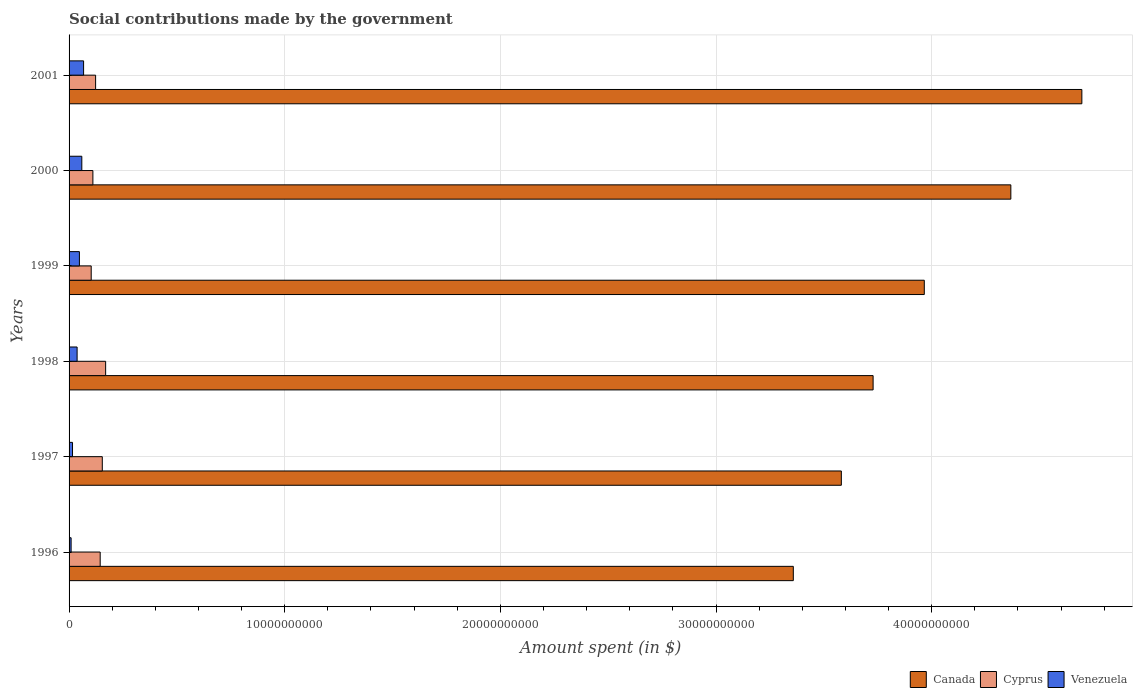How many different coloured bars are there?
Keep it short and to the point. 3. How many groups of bars are there?
Your response must be concise. 6. How many bars are there on the 4th tick from the top?
Provide a succinct answer. 3. How many bars are there on the 2nd tick from the bottom?
Offer a very short reply. 3. What is the amount spent on social contributions in Venezuela in 2001?
Keep it short and to the point. 6.74e+08. Across all years, what is the maximum amount spent on social contributions in Venezuela?
Offer a terse response. 6.74e+08. Across all years, what is the minimum amount spent on social contributions in Canada?
Provide a succinct answer. 3.36e+1. In which year was the amount spent on social contributions in Cyprus minimum?
Your answer should be compact. 1999. What is the total amount spent on social contributions in Cyprus in the graph?
Your response must be concise. 8.04e+09. What is the difference between the amount spent on social contributions in Venezuela in 1996 and that in 1997?
Provide a succinct answer. -6.55e+07. What is the difference between the amount spent on social contributions in Canada in 1997 and the amount spent on social contributions in Cyprus in 1999?
Your response must be concise. 3.48e+1. What is the average amount spent on social contributions in Cyprus per year?
Give a very brief answer. 1.34e+09. In the year 1998, what is the difference between the amount spent on social contributions in Canada and amount spent on social contributions in Cyprus?
Offer a terse response. 3.56e+1. In how many years, is the amount spent on social contributions in Cyprus greater than 46000000000 $?
Ensure brevity in your answer.  0. What is the ratio of the amount spent on social contributions in Cyprus in 1999 to that in 2001?
Offer a terse response. 0.83. Is the difference between the amount spent on social contributions in Canada in 1997 and 1998 greater than the difference between the amount spent on social contributions in Cyprus in 1997 and 1998?
Ensure brevity in your answer.  No. What is the difference between the highest and the second highest amount spent on social contributions in Cyprus?
Offer a terse response. 1.55e+08. What is the difference between the highest and the lowest amount spent on social contributions in Venezuela?
Provide a succinct answer. 5.79e+08. Is the sum of the amount spent on social contributions in Canada in 1996 and 2000 greater than the maximum amount spent on social contributions in Venezuela across all years?
Provide a short and direct response. Yes. What does the 2nd bar from the top in 1997 represents?
Your response must be concise. Cyprus. What does the 3rd bar from the bottom in 2000 represents?
Your response must be concise. Venezuela. Are all the bars in the graph horizontal?
Your answer should be compact. Yes. What is the difference between two consecutive major ticks on the X-axis?
Offer a very short reply. 1.00e+1. Are the values on the major ticks of X-axis written in scientific E-notation?
Provide a succinct answer. No. Does the graph contain grids?
Keep it short and to the point. Yes. Where does the legend appear in the graph?
Your answer should be very brief. Bottom right. How many legend labels are there?
Provide a short and direct response. 3. How are the legend labels stacked?
Ensure brevity in your answer.  Horizontal. What is the title of the graph?
Offer a very short reply. Social contributions made by the government. Does "United Arab Emirates" appear as one of the legend labels in the graph?
Give a very brief answer. No. What is the label or title of the X-axis?
Offer a very short reply. Amount spent (in $). What is the label or title of the Y-axis?
Keep it short and to the point. Years. What is the Amount spent (in $) in Canada in 1996?
Offer a very short reply. 3.36e+1. What is the Amount spent (in $) in Cyprus in 1996?
Give a very brief answer. 1.44e+09. What is the Amount spent (in $) of Venezuela in 1996?
Your answer should be very brief. 9.45e+07. What is the Amount spent (in $) in Canada in 1997?
Your answer should be compact. 3.58e+1. What is the Amount spent (in $) in Cyprus in 1997?
Keep it short and to the point. 1.54e+09. What is the Amount spent (in $) of Venezuela in 1997?
Offer a very short reply. 1.60e+08. What is the Amount spent (in $) in Canada in 1998?
Your answer should be compact. 3.73e+1. What is the Amount spent (in $) in Cyprus in 1998?
Make the answer very short. 1.70e+09. What is the Amount spent (in $) of Venezuela in 1998?
Your answer should be very brief. 3.72e+08. What is the Amount spent (in $) of Canada in 1999?
Offer a terse response. 3.97e+1. What is the Amount spent (in $) of Cyprus in 1999?
Offer a very short reply. 1.03e+09. What is the Amount spent (in $) of Venezuela in 1999?
Give a very brief answer. 4.79e+08. What is the Amount spent (in $) in Canada in 2000?
Give a very brief answer. 4.37e+1. What is the Amount spent (in $) in Cyprus in 2000?
Make the answer very short. 1.10e+09. What is the Amount spent (in $) in Venezuela in 2000?
Your response must be concise. 5.91e+08. What is the Amount spent (in $) in Canada in 2001?
Give a very brief answer. 4.70e+1. What is the Amount spent (in $) of Cyprus in 2001?
Offer a terse response. 1.23e+09. What is the Amount spent (in $) in Venezuela in 2001?
Keep it short and to the point. 6.74e+08. Across all years, what is the maximum Amount spent (in $) in Canada?
Keep it short and to the point. 4.70e+1. Across all years, what is the maximum Amount spent (in $) of Cyprus?
Offer a very short reply. 1.70e+09. Across all years, what is the maximum Amount spent (in $) of Venezuela?
Offer a terse response. 6.74e+08. Across all years, what is the minimum Amount spent (in $) of Canada?
Provide a succinct answer. 3.36e+1. Across all years, what is the minimum Amount spent (in $) in Cyprus?
Your response must be concise. 1.03e+09. Across all years, what is the minimum Amount spent (in $) in Venezuela?
Provide a short and direct response. 9.45e+07. What is the total Amount spent (in $) in Canada in the graph?
Keep it short and to the point. 2.37e+11. What is the total Amount spent (in $) in Cyprus in the graph?
Your answer should be very brief. 8.04e+09. What is the total Amount spent (in $) in Venezuela in the graph?
Make the answer very short. 2.37e+09. What is the difference between the Amount spent (in $) of Canada in 1996 and that in 1997?
Make the answer very short. -2.23e+09. What is the difference between the Amount spent (in $) in Cyprus in 1996 and that in 1997?
Keep it short and to the point. -9.78e+07. What is the difference between the Amount spent (in $) in Venezuela in 1996 and that in 1997?
Your response must be concise. -6.55e+07. What is the difference between the Amount spent (in $) of Canada in 1996 and that in 1998?
Offer a terse response. -3.70e+09. What is the difference between the Amount spent (in $) of Cyprus in 1996 and that in 1998?
Make the answer very short. -2.53e+08. What is the difference between the Amount spent (in $) in Venezuela in 1996 and that in 1998?
Give a very brief answer. -2.78e+08. What is the difference between the Amount spent (in $) of Canada in 1996 and that in 1999?
Provide a succinct answer. -6.07e+09. What is the difference between the Amount spent (in $) of Cyprus in 1996 and that in 1999?
Your response must be concise. 4.17e+08. What is the difference between the Amount spent (in $) of Venezuela in 1996 and that in 1999?
Your response must be concise. -3.85e+08. What is the difference between the Amount spent (in $) of Canada in 1996 and that in 2000?
Keep it short and to the point. -1.01e+1. What is the difference between the Amount spent (in $) in Cyprus in 1996 and that in 2000?
Offer a terse response. 3.38e+08. What is the difference between the Amount spent (in $) in Venezuela in 1996 and that in 2000?
Offer a terse response. -4.96e+08. What is the difference between the Amount spent (in $) in Canada in 1996 and that in 2001?
Offer a terse response. -1.34e+1. What is the difference between the Amount spent (in $) in Cyprus in 1996 and that in 2001?
Provide a succinct answer. 2.12e+08. What is the difference between the Amount spent (in $) in Venezuela in 1996 and that in 2001?
Keep it short and to the point. -5.79e+08. What is the difference between the Amount spent (in $) of Canada in 1997 and that in 1998?
Your answer should be very brief. -1.47e+09. What is the difference between the Amount spent (in $) of Cyprus in 1997 and that in 1998?
Your answer should be very brief. -1.55e+08. What is the difference between the Amount spent (in $) in Venezuela in 1997 and that in 1998?
Your answer should be compact. -2.12e+08. What is the difference between the Amount spent (in $) of Canada in 1997 and that in 1999?
Your answer should be very brief. -3.85e+09. What is the difference between the Amount spent (in $) in Cyprus in 1997 and that in 1999?
Your answer should be compact. 5.14e+08. What is the difference between the Amount spent (in $) in Venezuela in 1997 and that in 1999?
Keep it short and to the point. -3.19e+08. What is the difference between the Amount spent (in $) of Canada in 1997 and that in 2000?
Make the answer very short. -7.86e+09. What is the difference between the Amount spent (in $) of Cyprus in 1997 and that in 2000?
Your answer should be compact. 4.36e+08. What is the difference between the Amount spent (in $) of Venezuela in 1997 and that in 2000?
Offer a very short reply. -4.30e+08. What is the difference between the Amount spent (in $) in Canada in 1997 and that in 2001?
Give a very brief answer. -1.12e+1. What is the difference between the Amount spent (in $) of Cyprus in 1997 and that in 2001?
Give a very brief answer. 3.10e+08. What is the difference between the Amount spent (in $) in Venezuela in 1997 and that in 2001?
Make the answer very short. -5.14e+08. What is the difference between the Amount spent (in $) of Canada in 1998 and that in 1999?
Give a very brief answer. -2.37e+09. What is the difference between the Amount spent (in $) in Cyprus in 1998 and that in 1999?
Offer a terse response. 6.69e+08. What is the difference between the Amount spent (in $) of Venezuela in 1998 and that in 1999?
Your answer should be compact. -1.07e+08. What is the difference between the Amount spent (in $) of Canada in 1998 and that in 2000?
Make the answer very short. -6.39e+09. What is the difference between the Amount spent (in $) in Cyprus in 1998 and that in 2000?
Your response must be concise. 5.91e+08. What is the difference between the Amount spent (in $) in Venezuela in 1998 and that in 2000?
Make the answer very short. -2.18e+08. What is the difference between the Amount spent (in $) of Canada in 1998 and that in 2001?
Keep it short and to the point. -9.68e+09. What is the difference between the Amount spent (in $) of Cyprus in 1998 and that in 2001?
Your answer should be very brief. 4.65e+08. What is the difference between the Amount spent (in $) of Venezuela in 1998 and that in 2001?
Give a very brief answer. -3.01e+08. What is the difference between the Amount spent (in $) of Canada in 1999 and that in 2000?
Ensure brevity in your answer.  -4.01e+09. What is the difference between the Amount spent (in $) in Cyprus in 1999 and that in 2000?
Offer a very short reply. -7.84e+07. What is the difference between the Amount spent (in $) of Venezuela in 1999 and that in 2000?
Your response must be concise. -1.11e+08. What is the difference between the Amount spent (in $) of Canada in 1999 and that in 2001?
Ensure brevity in your answer.  -7.31e+09. What is the difference between the Amount spent (in $) in Cyprus in 1999 and that in 2001?
Provide a short and direct response. -2.04e+08. What is the difference between the Amount spent (in $) of Venezuela in 1999 and that in 2001?
Keep it short and to the point. -1.94e+08. What is the difference between the Amount spent (in $) of Canada in 2000 and that in 2001?
Your answer should be very brief. -3.29e+09. What is the difference between the Amount spent (in $) in Cyprus in 2000 and that in 2001?
Provide a succinct answer. -1.26e+08. What is the difference between the Amount spent (in $) of Venezuela in 2000 and that in 2001?
Provide a succinct answer. -8.30e+07. What is the difference between the Amount spent (in $) of Canada in 1996 and the Amount spent (in $) of Cyprus in 1997?
Your response must be concise. 3.20e+1. What is the difference between the Amount spent (in $) of Canada in 1996 and the Amount spent (in $) of Venezuela in 1997?
Your answer should be compact. 3.34e+1. What is the difference between the Amount spent (in $) in Cyprus in 1996 and the Amount spent (in $) in Venezuela in 1997?
Give a very brief answer. 1.28e+09. What is the difference between the Amount spent (in $) of Canada in 1996 and the Amount spent (in $) of Cyprus in 1998?
Provide a short and direct response. 3.19e+1. What is the difference between the Amount spent (in $) in Canada in 1996 and the Amount spent (in $) in Venezuela in 1998?
Your answer should be very brief. 3.32e+1. What is the difference between the Amount spent (in $) in Cyprus in 1996 and the Amount spent (in $) in Venezuela in 1998?
Provide a short and direct response. 1.07e+09. What is the difference between the Amount spent (in $) in Canada in 1996 and the Amount spent (in $) in Cyprus in 1999?
Offer a terse response. 3.26e+1. What is the difference between the Amount spent (in $) of Canada in 1996 and the Amount spent (in $) of Venezuela in 1999?
Offer a terse response. 3.31e+1. What is the difference between the Amount spent (in $) of Cyprus in 1996 and the Amount spent (in $) of Venezuela in 1999?
Provide a succinct answer. 9.64e+08. What is the difference between the Amount spent (in $) in Canada in 1996 and the Amount spent (in $) in Cyprus in 2000?
Keep it short and to the point. 3.25e+1. What is the difference between the Amount spent (in $) of Canada in 1996 and the Amount spent (in $) of Venezuela in 2000?
Offer a very short reply. 3.30e+1. What is the difference between the Amount spent (in $) in Cyprus in 1996 and the Amount spent (in $) in Venezuela in 2000?
Offer a terse response. 8.53e+08. What is the difference between the Amount spent (in $) in Canada in 1996 and the Amount spent (in $) in Cyprus in 2001?
Offer a terse response. 3.24e+1. What is the difference between the Amount spent (in $) in Canada in 1996 and the Amount spent (in $) in Venezuela in 2001?
Give a very brief answer. 3.29e+1. What is the difference between the Amount spent (in $) of Cyprus in 1996 and the Amount spent (in $) of Venezuela in 2001?
Keep it short and to the point. 7.69e+08. What is the difference between the Amount spent (in $) in Canada in 1997 and the Amount spent (in $) in Cyprus in 1998?
Give a very brief answer. 3.41e+1. What is the difference between the Amount spent (in $) in Canada in 1997 and the Amount spent (in $) in Venezuela in 1998?
Your answer should be very brief. 3.54e+1. What is the difference between the Amount spent (in $) in Cyprus in 1997 and the Amount spent (in $) in Venezuela in 1998?
Give a very brief answer. 1.17e+09. What is the difference between the Amount spent (in $) of Canada in 1997 and the Amount spent (in $) of Cyprus in 1999?
Keep it short and to the point. 3.48e+1. What is the difference between the Amount spent (in $) of Canada in 1997 and the Amount spent (in $) of Venezuela in 1999?
Offer a terse response. 3.53e+1. What is the difference between the Amount spent (in $) of Cyprus in 1997 and the Amount spent (in $) of Venezuela in 1999?
Offer a terse response. 1.06e+09. What is the difference between the Amount spent (in $) of Canada in 1997 and the Amount spent (in $) of Cyprus in 2000?
Offer a very short reply. 3.47e+1. What is the difference between the Amount spent (in $) in Canada in 1997 and the Amount spent (in $) in Venezuela in 2000?
Keep it short and to the point. 3.52e+1. What is the difference between the Amount spent (in $) in Cyprus in 1997 and the Amount spent (in $) in Venezuela in 2000?
Offer a very short reply. 9.50e+08. What is the difference between the Amount spent (in $) of Canada in 1997 and the Amount spent (in $) of Cyprus in 2001?
Offer a terse response. 3.46e+1. What is the difference between the Amount spent (in $) of Canada in 1997 and the Amount spent (in $) of Venezuela in 2001?
Give a very brief answer. 3.51e+1. What is the difference between the Amount spent (in $) of Cyprus in 1997 and the Amount spent (in $) of Venezuela in 2001?
Offer a terse response. 8.67e+08. What is the difference between the Amount spent (in $) in Canada in 1998 and the Amount spent (in $) in Cyprus in 1999?
Offer a very short reply. 3.63e+1. What is the difference between the Amount spent (in $) of Canada in 1998 and the Amount spent (in $) of Venezuela in 1999?
Provide a succinct answer. 3.68e+1. What is the difference between the Amount spent (in $) in Cyprus in 1998 and the Amount spent (in $) in Venezuela in 1999?
Make the answer very short. 1.22e+09. What is the difference between the Amount spent (in $) in Canada in 1998 and the Amount spent (in $) in Cyprus in 2000?
Your answer should be very brief. 3.62e+1. What is the difference between the Amount spent (in $) in Canada in 1998 and the Amount spent (in $) in Venezuela in 2000?
Ensure brevity in your answer.  3.67e+1. What is the difference between the Amount spent (in $) in Cyprus in 1998 and the Amount spent (in $) in Venezuela in 2000?
Provide a succinct answer. 1.11e+09. What is the difference between the Amount spent (in $) of Canada in 1998 and the Amount spent (in $) of Cyprus in 2001?
Give a very brief answer. 3.61e+1. What is the difference between the Amount spent (in $) of Canada in 1998 and the Amount spent (in $) of Venezuela in 2001?
Offer a very short reply. 3.66e+1. What is the difference between the Amount spent (in $) in Cyprus in 1998 and the Amount spent (in $) in Venezuela in 2001?
Keep it short and to the point. 1.02e+09. What is the difference between the Amount spent (in $) in Canada in 1999 and the Amount spent (in $) in Cyprus in 2000?
Offer a very short reply. 3.86e+1. What is the difference between the Amount spent (in $) in Canada in 1999 and the Amount spent (in $) in Venezuela in 2000?
Your answer should be very brief. 3.91e+1. What is the difference between the Amount spent (in $) in Cyprus in 1999 and the Amount spent (in $) in Venezuela in 2000?
Give a very brief answer. 4.36e+08. What is the difference between the Amount spent (in $) of Canada in 1999 and the Amount spent (in $) of Cyprus in 2001?
Provide a short and direct response. 3.84e+1. What is the difference between the Amount spent (in $) of Canada in 1999 and the Amount spent (in $) of Venezuela in 2001?
Provide a short and direct response. 3.90e+1. What is the difference between the Amount spent (in $) in Cyprus in 1999 and the Amount spent (in $) in Venezuela in 2001?
Offer a terse response. 3.53e+08. What is the difference between the Amount spent (in $) of Canada in 2000 and the Amount spent (in $) of Cyprus in 2001?
Make the answer very short. 4.24e+1. What is the difference between the Amount spent (in $) of Canada in 2000 and the Amount spent (in $) of Venezuela in 2001?
Your answer should be very brief. 4.30e+1. What is the difference between the Amount spent (in $) in Cyprus in 2000 and the Amount spent (in $) in Venezuela in 2001?
Make the answer very short. 4.31e+08. What is the average Amount spent (in $) of Canada per year?
Offer a terse response. 3.95e+1. What is the average Amount spent (in $) of Cyprus per year?
Your response must be concise. 1.34e+09. What is the average Amount spent (in $) of Venezuela per year?
Offer a terse response. 3.95e+08. In the year 1996, what is the difference between the Amount spent (in $) of Canada and Amount spent (in $) of Cyprus?
Keep it short and to the point. 3.21e+1. In the year 1996, what is the difference between the Amount spent (in $) in Canada and Amount spent (in $) in Venezuela?
Make the answer very short. 3.35e+1. In the year 1996, what is the difference between the Amount spent (in $) in Cyprus and Amount spent (in $) in Venezuela?
Provide a succinct answer. 1.35e+09. In the year 1997, what is the difference between the Amount spent (in $) in Canada and Amount spent (in $) in Cyprus?
Offer a terse response. 3.43e+1. In the year 1997, what is the difference between the Amount spent (in $) of Canada and Amount spent (in $) of Venezuela?
Offer a very short reply. 3.57e+1. In the year 1997, what is the difference between the Amount spent (in $) of Cyprus and Amount spent (in $) of Venezuela?
Provide a succinct answer. 1.38e+09. In the year 1998, what is the difference between the Amount spent (in $) in Canada and Amount spent (in $) in Cyprus?
Your answer should be compact. 3.56e+1. In the year 1998, what is the difference between the Amount spent (in $) in Canada and Amount spent (in $) in Venezuela?
Give a very brief answer. 3.69e+1. In the year 1998, what is the difference between the Amount spent (in $) of Cyprus and Amount spent (in $) of Venezuela?
Give a very brief answer. 1.32e+09. In the year 1999, what is the difference between the Amount spent (in $) in Canada and Amount spent (in $) in Cyprus?
Offer a very short reply. 3.86e+1. In the year 1999, what is the difference between the Amount spent (in $) in Canada and Amount spent (in $) in Venezuela?
Provide a succinct answer. 3.92e+1. In the year 1999, what is the difference between the Amount spent (in $) in Cyprus and Amount spent (in $) in Venezuela?
Make the answer very short. 5.47e+08. In the year 2000, what is the difference between the Amount spent (in $) of Canada and Amount spent (in $) of Cyprus?
Keep it short and to the point. 4.26e+1. In the year 2000, what is the difference between the Amount spent (in $) in Canada and Amount spent (in $) in Venezuela?
Ensure brevity in your answer.  4.31e+1. In the year 2000, what is the difference between the Amount spent (in $) of Cyprus and Amount spent (in $) of Venezuela?
Your answer should be compact. 5.14e+08. In the year 2001, what is the difference between the Amount spent (in $) of Canada and Amount spent (in $) of Cyprus?
Give a very brief answer. 4.57e+1. In the year 2001, what is the difference between the Amount spent (in $) in Canada and Amount spent (in $) in Venezuela?
Keep it short and to the point. 4.63e+1. In the year 2001, what is the difference between the Amount spent (in $) of Cyprus and Amount spent (in $) of Venezuela?
Your answer should be compact. 5.57e+08. What is the ratio of the Amount spent (in $) of Canada in 1996 to that in 1997?
Your answer should be compact. 0.94. What is the ratio of the Amount spent (in $) of Cyprus in 1996 to that in 1997?
Make the answer very short. 0.94. What is the ratio of the Amount spent (in $) in Venezuela in 1996 to that in 1997?
Your answer should be compact. 0.59. What is the ratio of the Amount spent (in $) in Canada in 1996 to that in 1998?
Provide a short and direct response. 0.9. What is the ratio of the Amount spent (in $) of Cyprus in 1996 to that in 1998?
Ensure brevity in your answer.  0.85. What is the ratio of the Amount spent (in $) in Venezuela in 1996 to that in 1998?
Your answer should be very brief. 0.25. What is the ratio of the Amount spent (in $) in Canada in 1996 to that in 1999?
Provide a short and direct response. 0.85. What is the ratio of the Amount spent (in $) of Cyprus in 1996 to that in 1999?
Your response must be concise. 1.41. What is the ratio of the Amount spent (in $) in Venezuela in 1996 to that in 1999?
Your answer should be very brief. 0.2. What is the ratio of the Amount spent (in $) of Canada in 1996 to that in 2000?
Keep it short and to the point. 0.77. What is the ratio of the Amount spent (in $) in Cyprus in 1996 to that in 2000?
Offer a very short reply. 1.31. What is the ratio of the Amount spent (in $) of Venezuela in 1996 to that in 2000?
Provide a succinct answer. 0.16. What is the ratio of the Amount spent (in $) in Canada in 1996 to that in 2001?
Ensure brevity in your answer.  0.72. What is the ratio of the Amount spent (in $) of Cyprus in 1996 to that in 2001?
Offer a very short reply. 1.17. What is the ratio of the Amount spent (in $) of Venezuela in 1996 to that in 2001?
Make the answer very short. 0.14. What is the ratio of the Amount spent (in $) in Canada in 1997 to that in 1998?
Keep it short and to the point. 0.96. What is the ratio of the Amount spent (in $) of Cyprus in 1997 to that in 1998?
Provide a short and direct response. 0.91. What is the ratio of the Amount spent (in $) in Venezuela in 1997 to that in 1998?
Ensure brevity in your answer.  0.43. What is the ratio of the Amount spent (in $) of Canada in 1997 to that in 1999?
Make the answer very short. 0.9. What is the ratio of the Amount spent (in $) in Cyprus in 1997 to that in 1999?
Offer a very short reply. 1.5. What is the ratio of the Amount spent (in $) in Venezuela in 1997 to that in 1999?
Your answer should be compact. 0.33. What is the ratio of the Amount spent (in $) in Canada in 1997 to that in 2000?
Make the answer very short. 0.82. What is the ratio of the Amount spent (in $) of Cyprus in 1997 to that in 2000?
Ensure brevity in your answer.  1.39. What is the ratio of the Amount spent (in $) of Venezuela in 1997 to that in 2000?
Give a very brief answer. 0.27. What is the ratio of the Amount spent (in $) in Canada in 1997 to that in 2001?
Provide a succinct answer. 0.76. What is the ratio of the Amount spent (in $) in Cyprus in 1997 to that in 2001?
Offer a terse response. 1.25. What is the ratio of the Amount spent (in $) of Venezuela in 1997 to that in 2001?
Keep it short and to the point. 0.24. What is the ratio of the Amount spent (in $) in Canada in 1998 to that in 1999?
Your answer should be very brief. 0.94. What is the ratio of the Amount spent (in $) in Cyprus in 1998 to that in 1999?
Your answer should be very brief. 1.65. What is the ratio of the Amount spent (in $) of Venezuela in 1998 to that in 1999?
Keep it short and to the point. 0.78. What is the ratio of the Amount spent (in $) of Canada in 1998 to that in 2000?
Give a very brief answer. 0.85. What is the ratio of the Amount spent (in $) of Cyprus in 1998 to that in 2000?
Offer a very short reply. 1.53. What is the ratio of the Amount spent (in $) of Venezuela in 1998 to that in 2000?
Give a very brief answer. 0.63. What is the ratio of the Amount spent (in $) of Canada in 1998 to that in 2001?
Give a very brief answer. 0.79. What is the ratio of the Amount spent (in $) in Cyprus in 1998 to that in 2001?
Keep it short and to the point. 1.38. What is the ratio of the Amount spent (in $) of Venezuela in 1998 to that in 2001?
Your answer should be compact. 0.55. What is the ratio of the Amount spent (in $) in Canada in 1999 to that in 2000?
Provide a short and direct response. 0.91. What is the ratio of the Amount spent (in $) in Cyprus in 1999 to that in 2000?
Make the answer very short. 0.93. What is the ratio of the Amount spent (in $) in Venezuela in 1999 to that in 2000?
Provide a short and direct response. 0.81. What is the ratio of the Amount spent (in $) of Canada in 1999 to that in 2001?
Make the answer very short. 0.84. What is the ratio of the Amount spent (in $) in Cyprus in 1999 to that in 2001?
Ensure brevity in your answer.  0.83. What is the ratio of the Amount spent (in $) in Venezuela in 1999 to that in 2001?
Your answer should be compact. 0.71. What is the ratio of the Amount spent (in $) of Canada in 2000 to that in 2001?
Make the answer very short. 0.93. What is the ratio of the Amount spent (in $) of Cyprus in 2000 to that in 2001?
Offer a terse response. 0.9. What is the ratio of the Amount spent (in $) in Venezuela in 2000 to that in 2001?
Keep it short and to the point. 0.88. What is the difference between the highest and the second highest Amount spent (in $) of Canada?
Ensure brevity in your answer.  3.29e+09. What is the difference between the highest and the second highest Amount spent (in $) of Cyprus?
Provide a succinct answer. 1.55e+08. What is the difference between the highest and the second highest Amount spent (in $) in Venezuela?
Offer a very short reply. 8.30e+07. What is the difference between the highest and the lowest Amount spent (in $) of Canada?
Your answer should be compact. 1.34e+1. What is the difference between the highest and the lowest Amount spent (in $) in Cyprus?
Keep it short and to the point. 6.69e+08. What is the difference between the highest and the lowest Amount spent (in $) in Venezuela?
Your answer should be compact. 5.79e+08. 